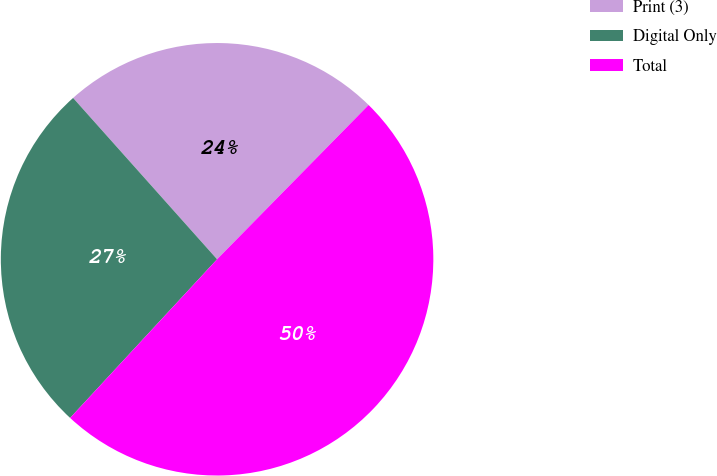Convert chart. <chart><loc_0><loc_0><loc_500><loc_500><pie_chart><fcel>Print (3)<fcel>Digital Only<fcel>Total<nl><fcel>23.95%<fcel>26.51%<fcel>49.53%<nl></chart> 